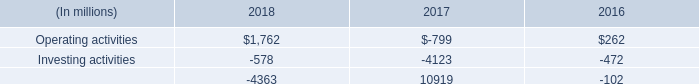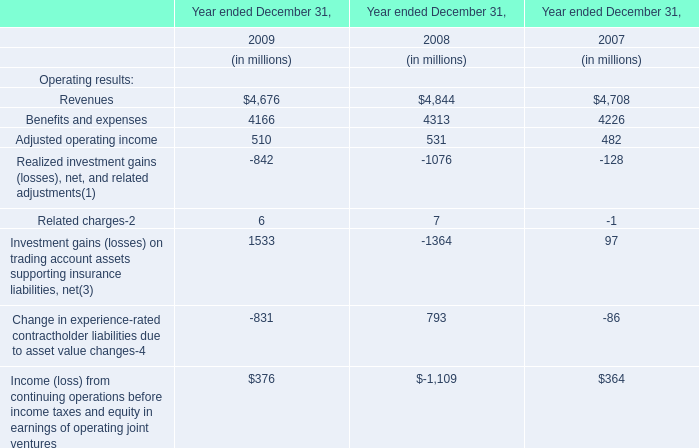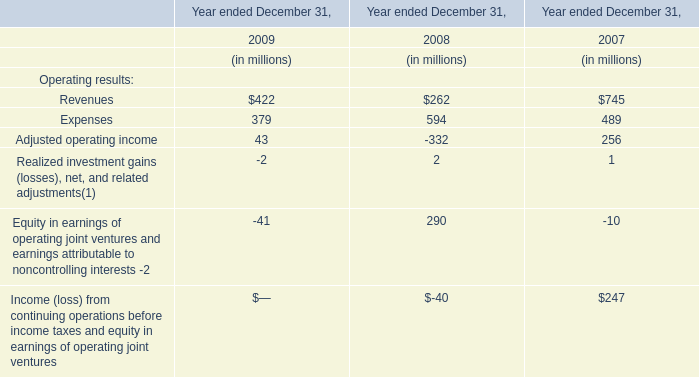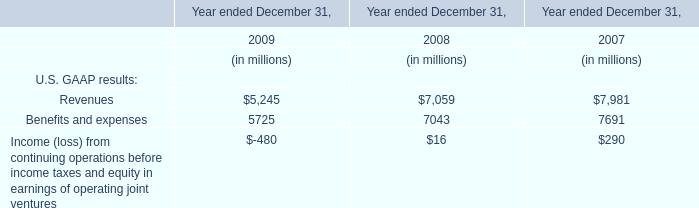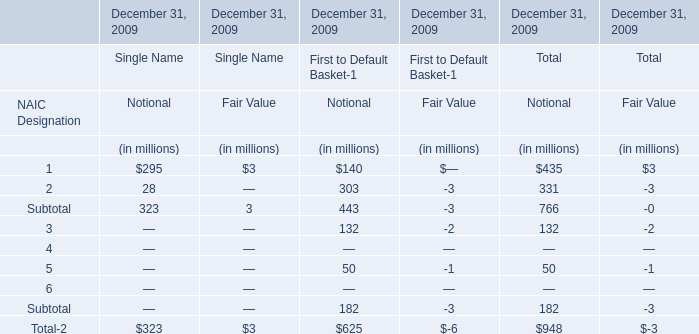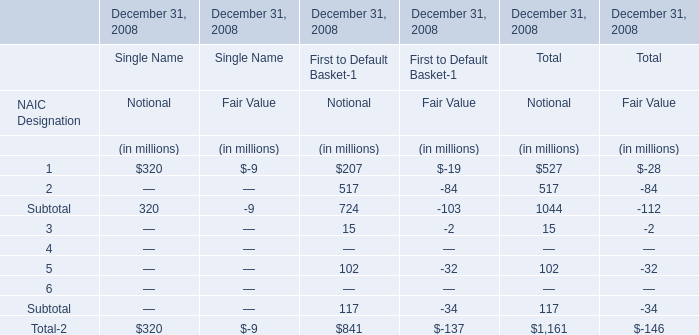what are the expenditures for capital assets in 2018 as a percentage of cash from operating activities in 2018? 
Computations: (995 / 1762)
Answer: 0.5647. 